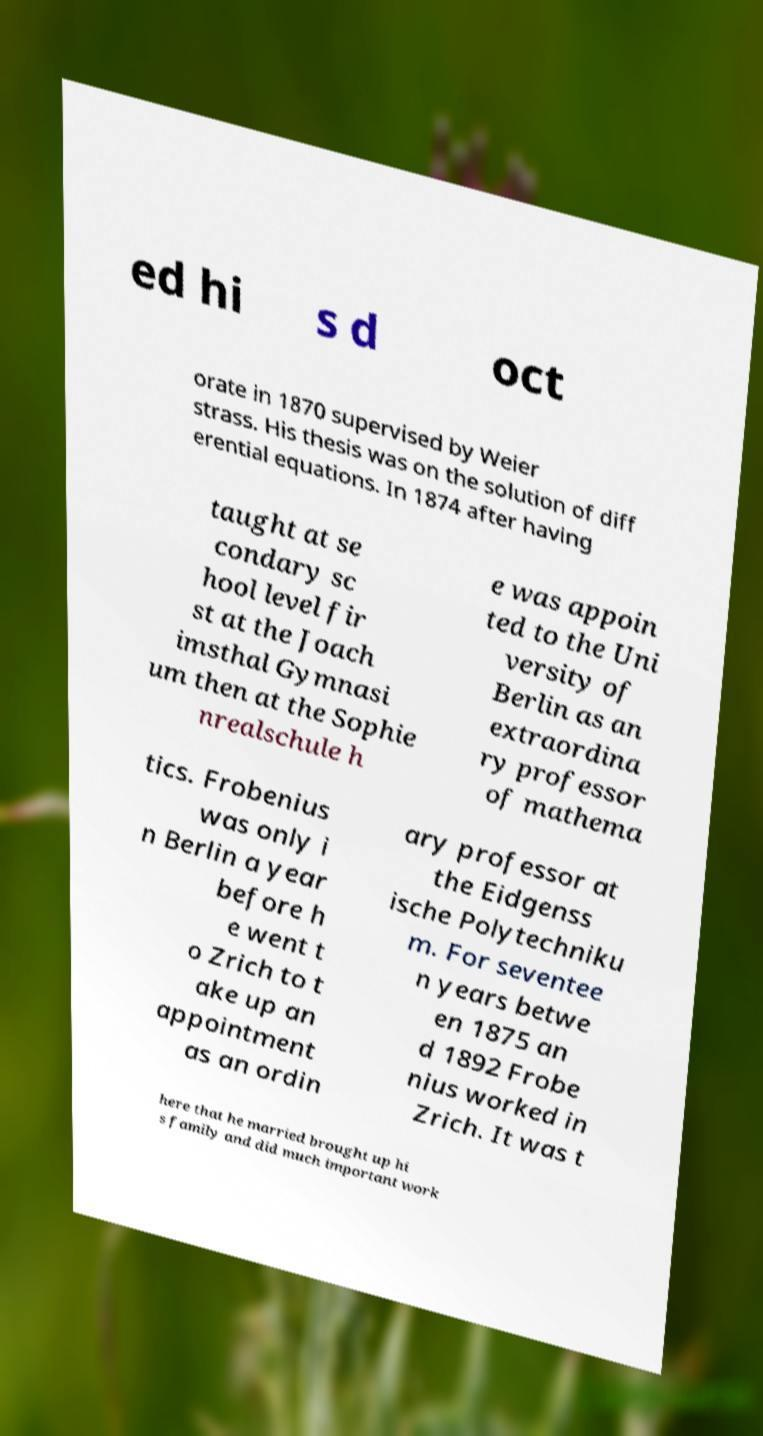Could you assist in decoding the text presented in this image and type it out clearly? ed hi s d oct orate in 1870 supervised by Weier strass. His thesis was on the solution of diff erential equations. In 1874 after having taught at se condary sc hool level fir st at the Joach imsthal Gymnasi um then at the Sophie nrealschule h e was appoin ted to the Uni versity of Berlin as an extraordina ry professor of mathema tics. Frobenius was only i n Berlin a year before h e went t o Zrich to t ake up an appointment as an ordin ary professor at the Eidgenss ische Polytechniku m. For seventee n years betwe en 1875 an d 1892 Frobe nius worked in Zrich. It was t here that he married brought up hi s family and did much important work 